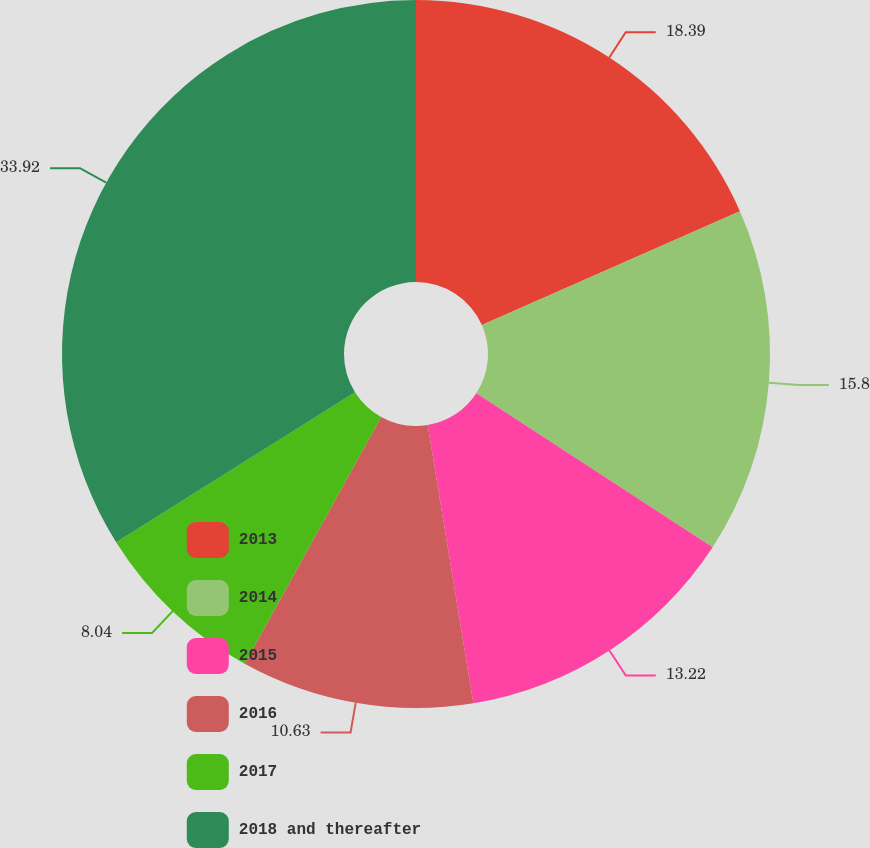Convert chart to OTSL. <chart><loc_0><loc_0><loc_500><loc_500><pie_chart><fcel>2013<fcel>2014<fcel>2015<fcel>2016<fcel>2017<fcel>2018 and thereafter<nl><fcel>18.39%<fcel>15.8%<fcel>13.22%<fcel>10.63%<fcel>8.04%<fcel>33.92%<nl></chart> 